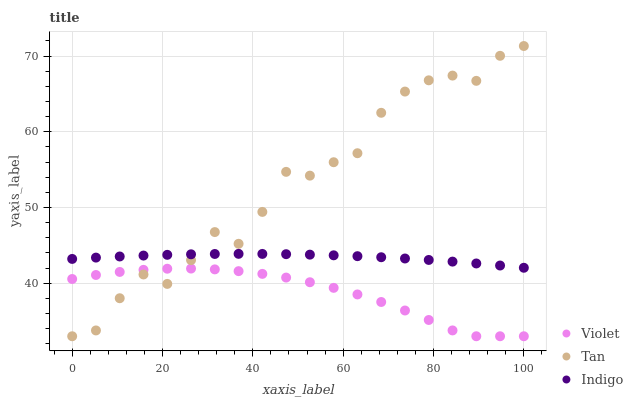Does Violet have the minimum area under the curve?
Answer yes or no. Yes. Does Tan have the maximum area under the curve?
Answer yes or no. Yes. Does Indigo have the minimum area under the curve?
Answer yes or no. No. Does Indigo have the maximum area under the curve?
Answer yes or no. No. Is Indigo the smoothest?
Answer yes or no. Yes. Is Tan the roughest?
Answer yes or no. Yes. Is Violet the smoothest?
Answer yes or no. No. Is Violet the roughest?
Answer yes or no. No. Does Tan have the lowest value?
Answer yes or no. Yes. Does Indigo have the lowest value?
Answer yes or no. No. Does Tan have the highest value?
Answer yes or no. Yes. Does Indigo have the highest value?
Answer yes or no. No. Is Violet less than Indigo?
Answer yes or no. Yes. Is Indigo greater than Violet?
Answer yes or no. Yes. Does Tan intersect Violet?
Answer yes or no. Yes. Is Tan less than Violet?
Answer yes or no. No. Is Tan greater than Violet?
Answer yes or no. No. Does Violet intersect Indigo?
Answer yes or no. No. 